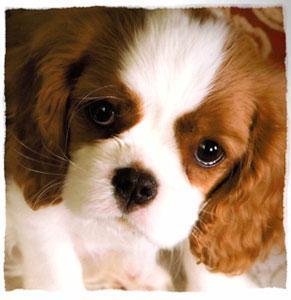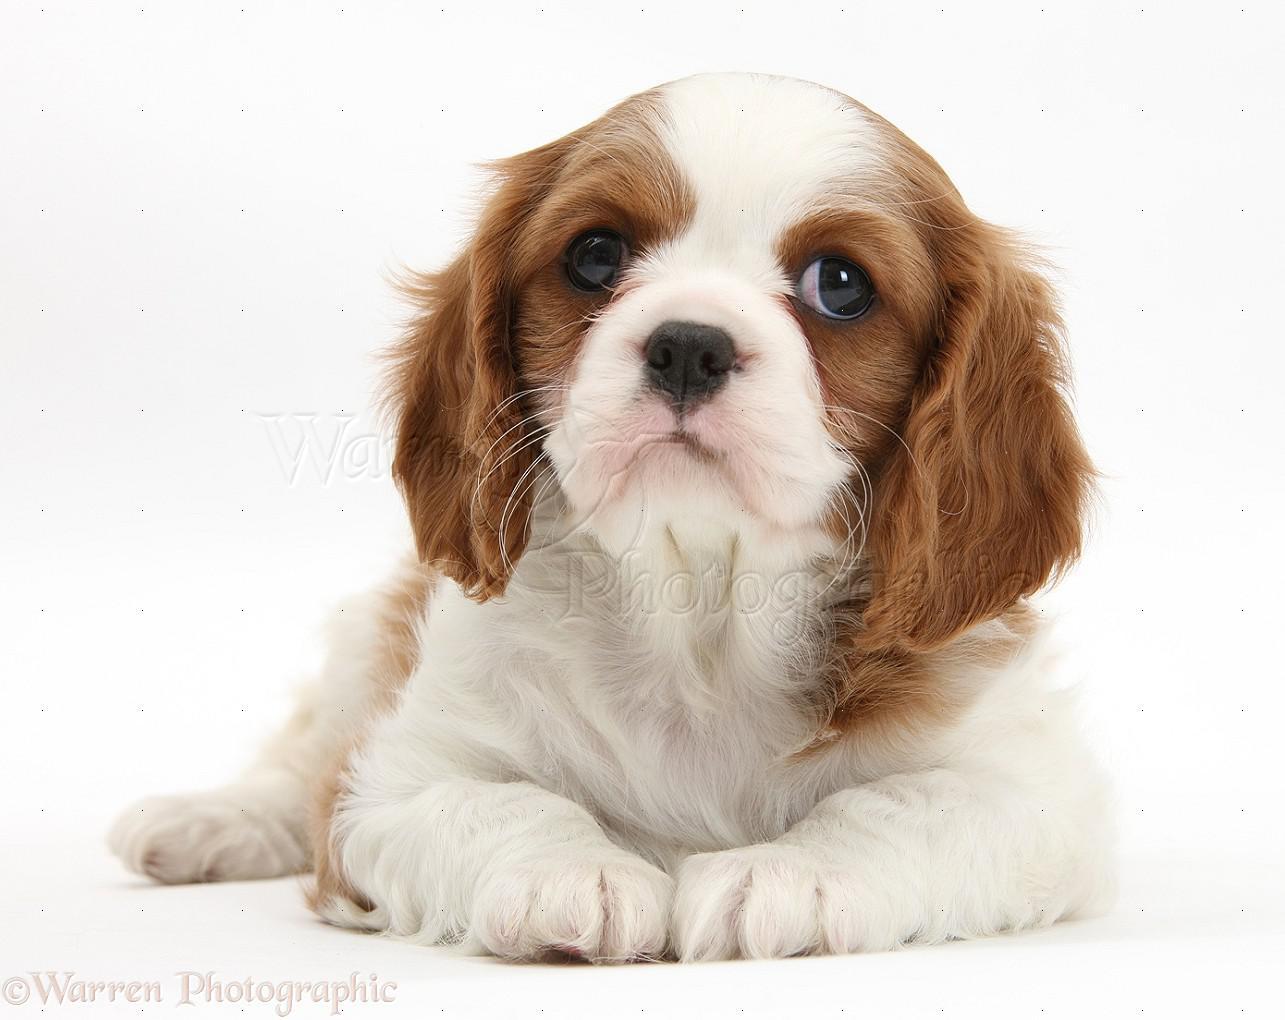The first image is the image on the left, the second image is the image on the right. Examine the images to the left and right. Is the description "One image features two animals, although one may not be a puppy, on a plain background." accurate? Answer yes or no. No. The first image is the image on the left, the second image is the image on the right. Assess this claim about the two images: "An image shows a brown and white spaniel posed next to another animal.". Correct or not? Answer yes or no. No. 